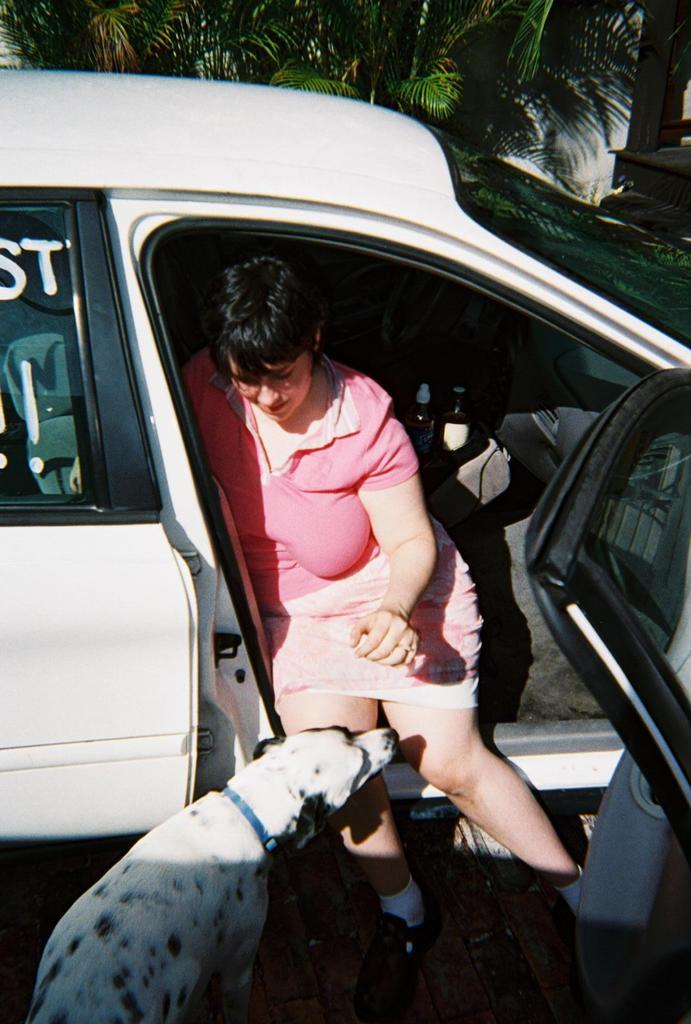What is the person in the image doing? There is a person sitting in a car in the image. What other living creature can be seen in the image? There is a dog at the bottom of the image. What type of vegetation is visible in the image? There are trees visible at the top of the image. What type of tent is visible in the image? There is no tent present in the image. What thought is the person in the car having in the image? We cannot determine the person's thoughts from the image. 